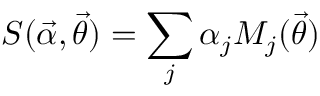Convert formula to latex. <formula><loc_0><loc_0><loc_500><loc_500>S ( \vec { \alpha } , \vec { \theta } ) = \sum _ { j } \alpha _ { j } M _ { j } ( \vec { \theta } )</formula> 